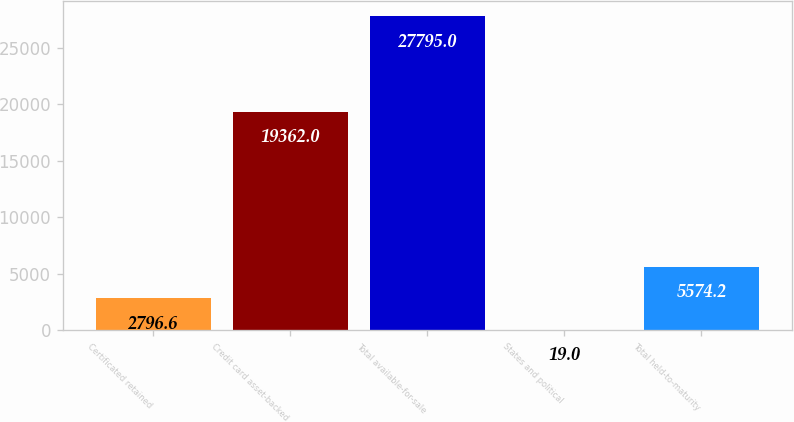<chart> <loc_0><loc_0><loc_500><loc_500><bar_chart><fcel>Certificated retained<fcel>Credit card asset-backed<fcel>Total available-for-sale<fcel>States and political<fcel>Total held-to-maturity<nl><fcel>2796.6<fcel>19362<fcel>27795<fcel>19<fcel>5574.2<nl></chart> 